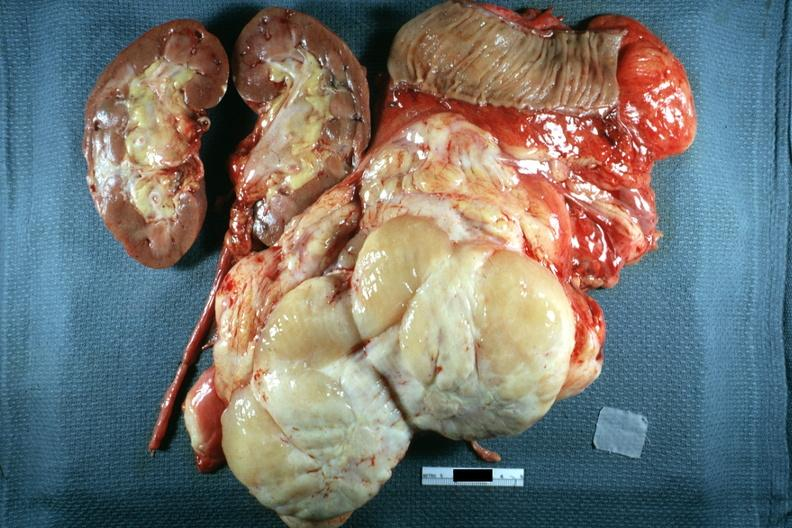s abdomen present?
Answer the question using a single word or phrase. Yes 